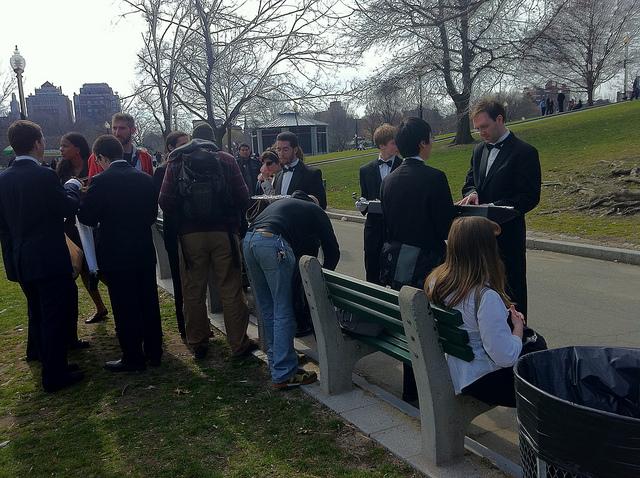Is there a garbage bag present?
Write a very short answer. Yes. How many chairs are visible?
Concise answer only. 1. Is there someone sitting on the bench?
Be succinct. Yes. Are there any leaves on the trees?
Answer briefly. No. Is anyone wearing a backpack?
Be succinct. Yes. 